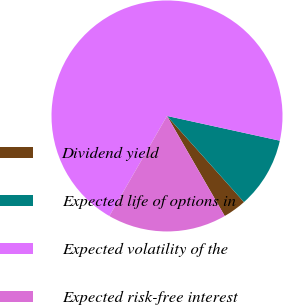Convert chart to OTSL. <chart><loc_0><loc_0><loc_500><loc_500><pie_chart><fcel>Dividend yield<fcel>Expected life of options in<fcel>Expected volatility of the<fcel>Expected risk-free interest<nl><fcel>3.28%<fcel>9.96%<fcel>70.12%<fcel>16.65%<nl></chart> 